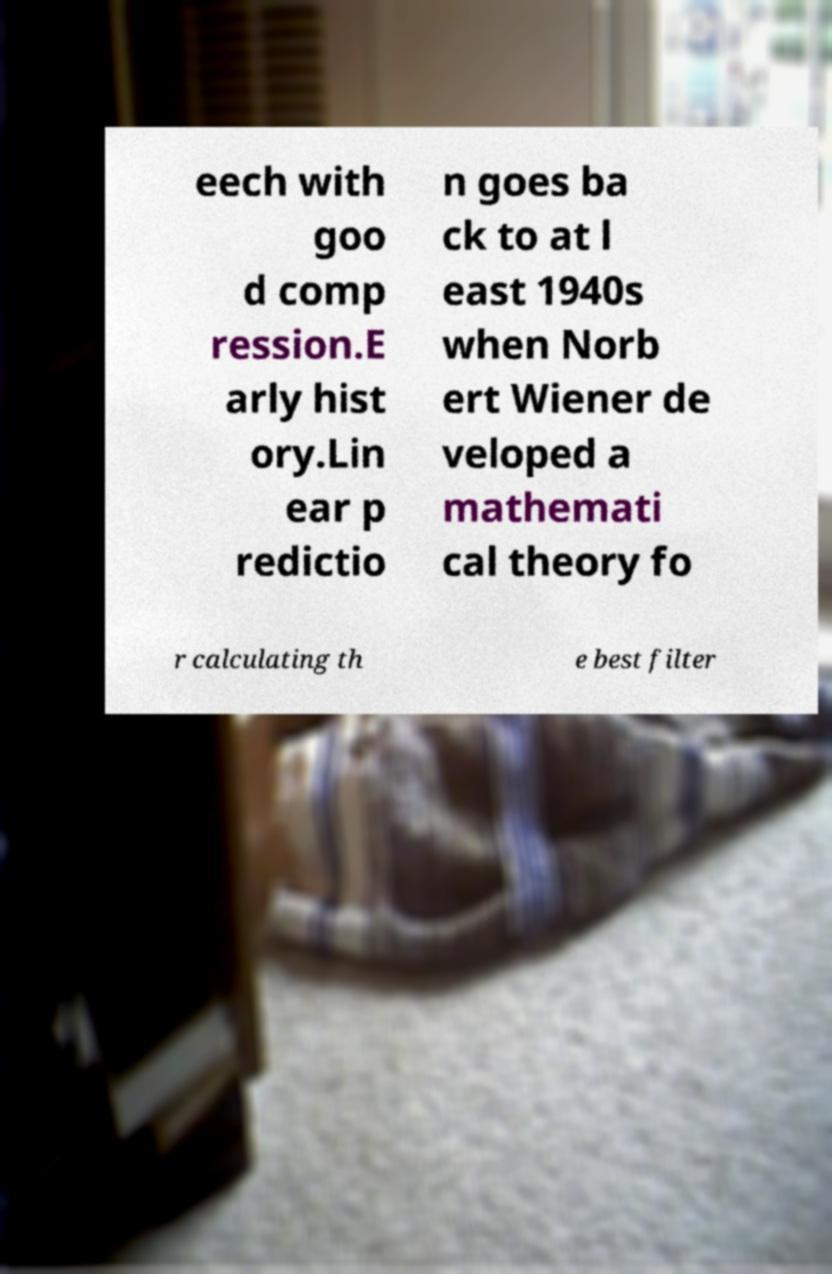I need the written content from this picture converted into text. Can you do that? eech with goo d comp ression.E arly hist ory.Lin ear p redictio n goes ba ck to at l east 1940s when Norb ert Wiener de veloped a mathemati cal theory fo r calculating th e best filter 